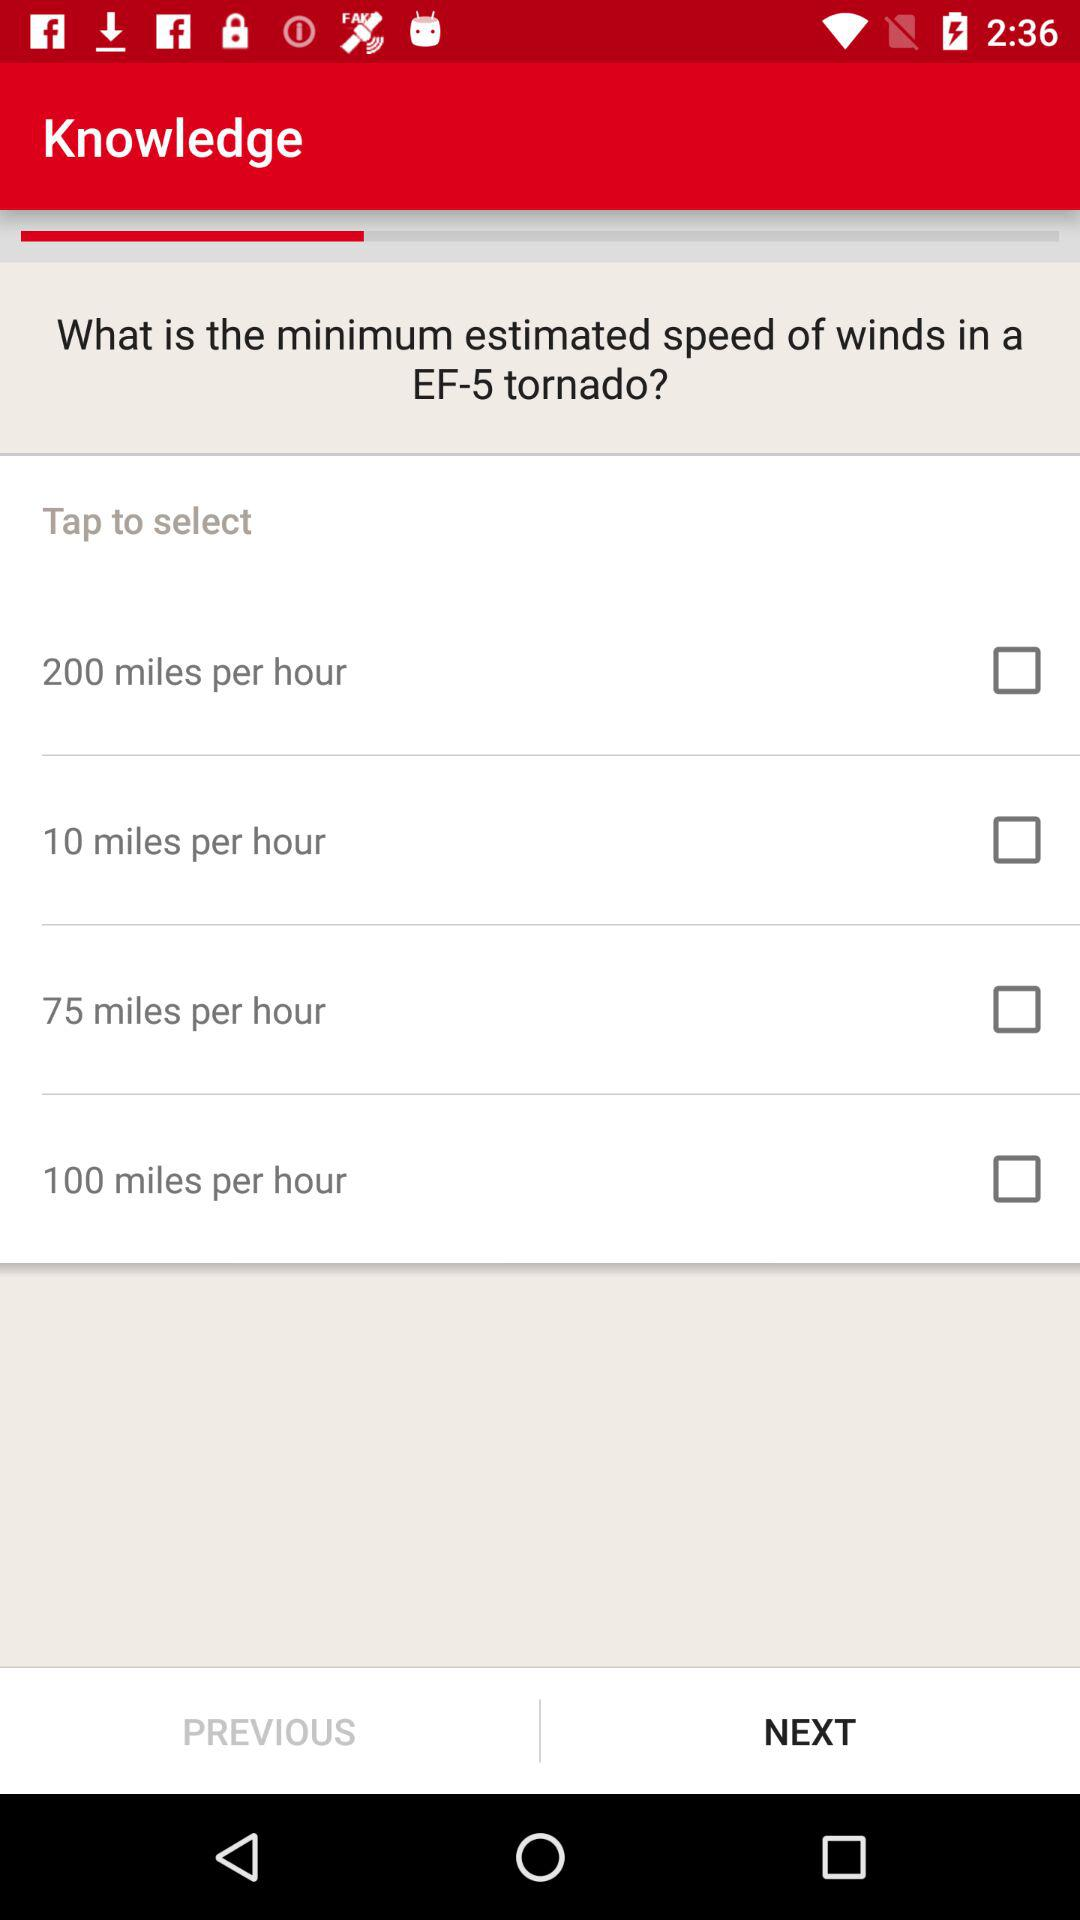What is the status of "10 miles per hour"? The status is "off". 